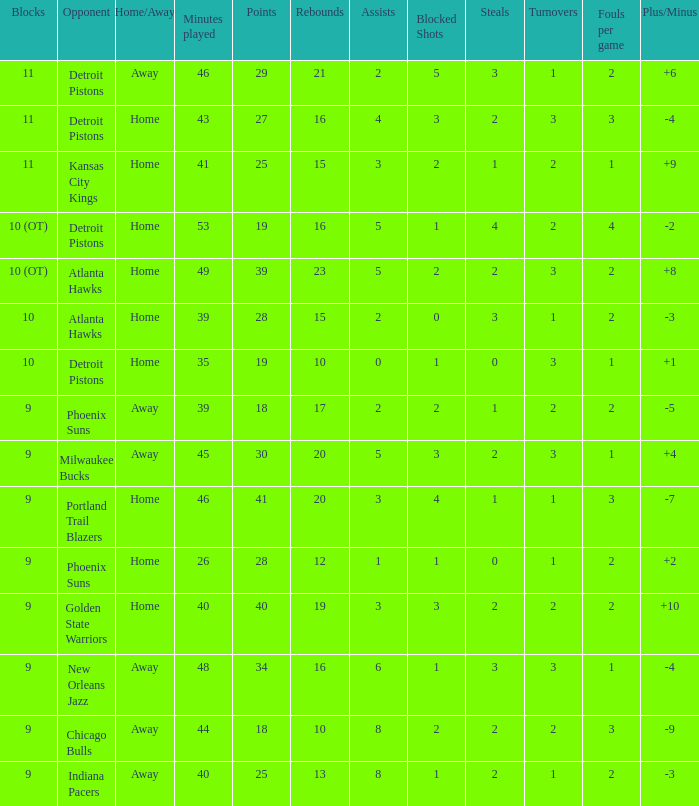Parse the table in full. {'header': ['Blocks', 'Opponent', 'Home/Away', 'Minutes played', 'Points', 'Rebounds', 'Assists', 'Blocked Shots', 'Steals', 'Turnovers', 'Fouls per game', 'Plus/Minus'], 'rows': [['11', 'Detroit Pistons', 'Away', '46', '29', '21', '2', '5', '3', '1', '2', '+6'], ['11', 'Detroit Pistons', 'Home', '43', '27', '16', '4', '3', '2', '3', '3', '-4'], ['11', 'Kansas City Kings', 'Home', '41', '25', '15', '3', '2', '1', '2', '1', '+9'], ['10 (OT)', 'Detroit Pistons', 'Home', '53', '19', '16', '5', '1', '4', '2', '4', '-2'], ['10 (OT)', 'Atlanta Hawks', 'Home', '49', '39', '23', '5', '2', '2', '3', '2', '+8'], ['10', 'Atlanta Hawks', 'Home', '39', '28', '15', '2', '0', '3', '1', '2', '-3'], ['10', 'Detroit Pistons', 'Home', '35', '19', '10', '0', '1', '0', '3', '1', '+1'], ['9', 'Phoenix Suns', 'Away', '39', '18', '17', '2', '2', '1', '2', '2', '-5'], ['9', 'Milwaukee Bucks', 'Away', '45', '30', '20', '5', '3', '2', '3', '1', '+4'], ['9', 'Portland Trail Blazers', 'Home', '46', '41', '20', '3', '4', '1', '1', '3', '-7'], ['9', 'Phoenix Suns', 'Home', '26', '28', '12', '1', '1', '0', '1', '2', '+2'], ['9', 'Golden State Warriors', 'Home', '40', '40', '19', '3', '3', '2', '2', '2', '+10'], ['9', 'New Orleans Jazz', 'Away', '48', '34', '16', '6', '1', '3', '3', '1', '-4'], ['9', 'Chicago Bulls', 'Away', '44', '18', '10', '8', '2', '2', '2', '3', '-9'], ['9', 'Indiana Pacers', 'Away', '40', '25', '13', '8', '1', '2', '1', '2', '-3']]} How many points were there when there were less than 16 rebounds and 5 assists? 0.0. 